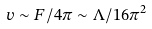Convert formula to latex. <formula><loc_0><loc_0><loc_500><loc_500>v \sim F / 4 \pi \sim \Lambda / 1 6 \pi ^ { 2 }</formula> 